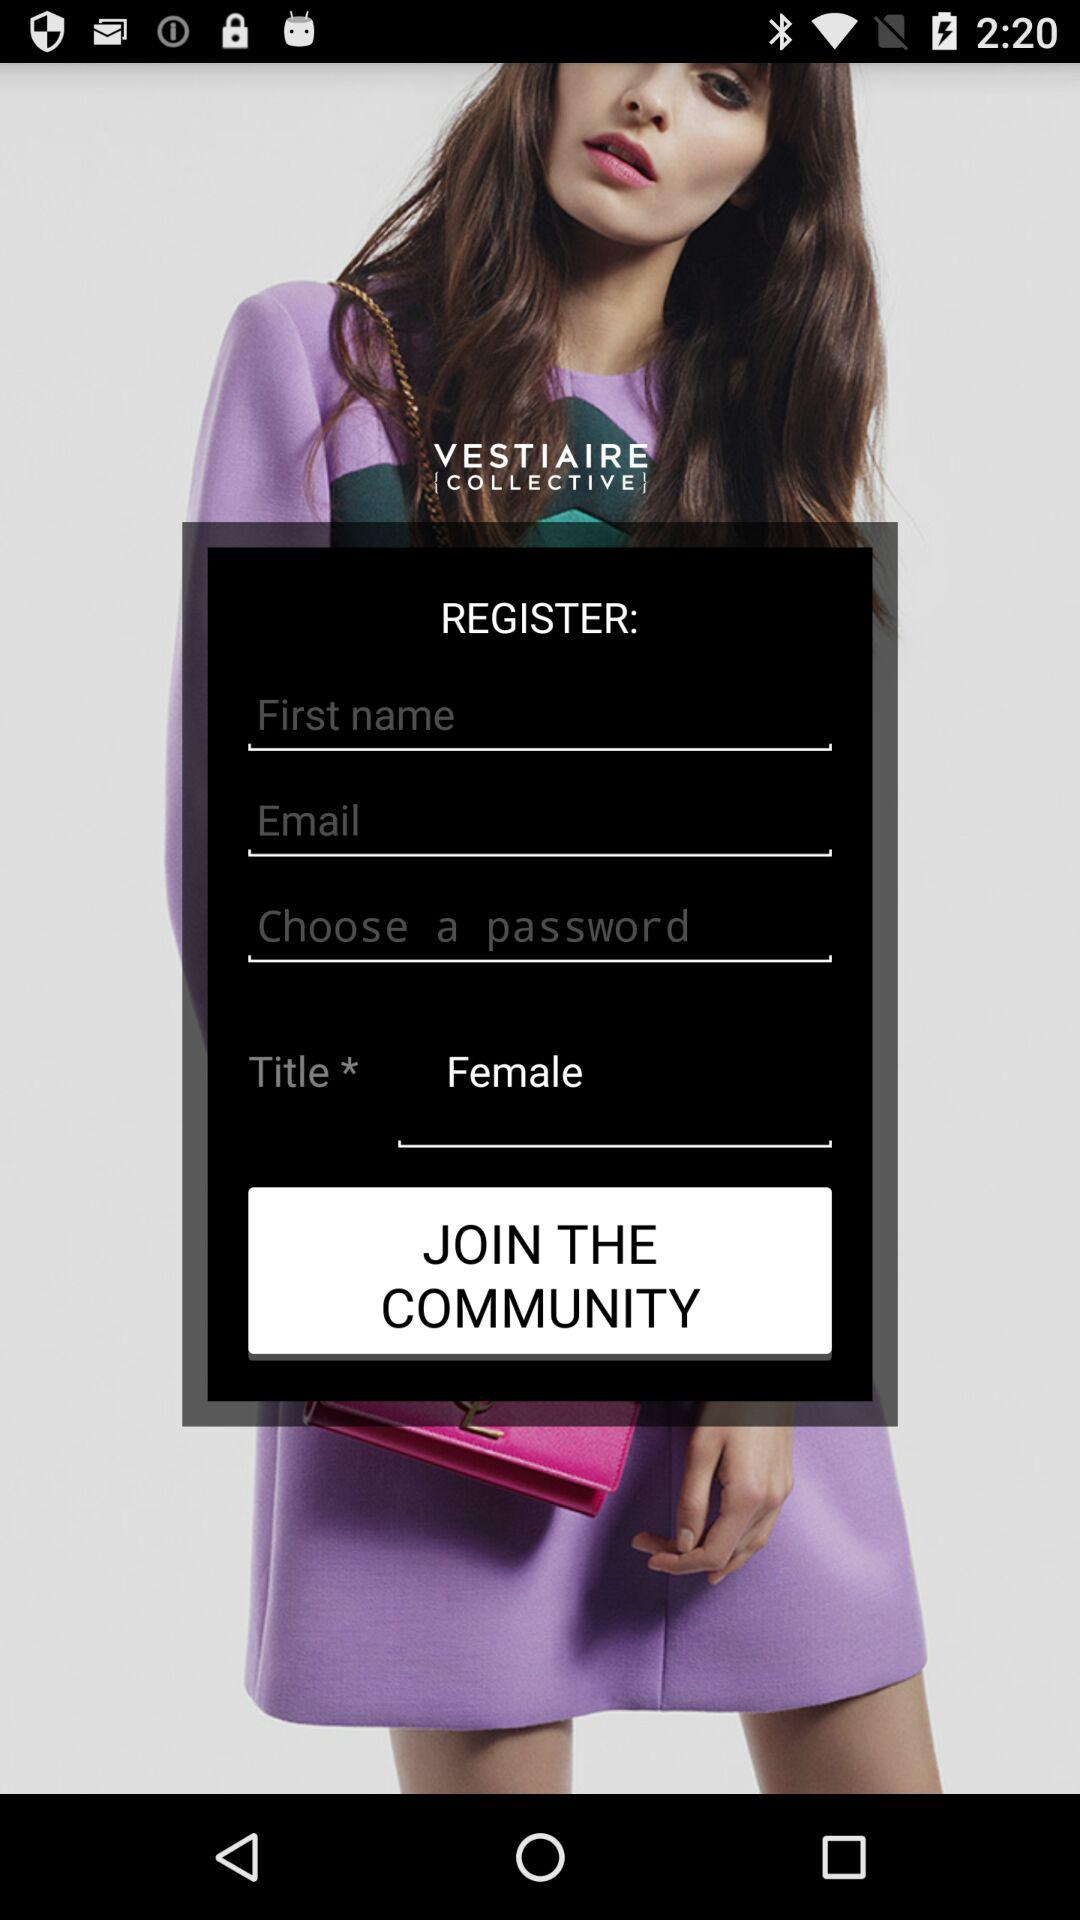What is the gender? The gender is female. 